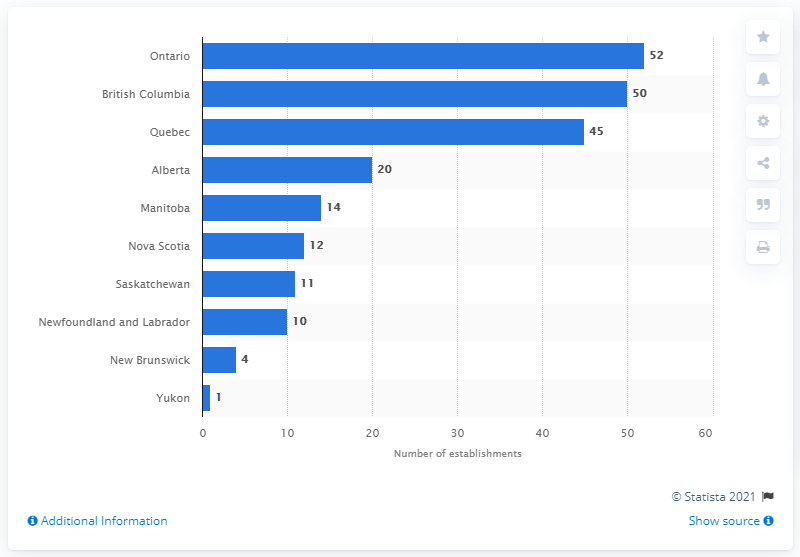Identify some key points in this picture. There were 52 soft drink and ice manufacturing establishments in Ontario as of June 2020. 